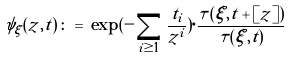<formula> <loc_0><loc_0><loc_500><loc_500>\psi _ { \xi } ( z , t ) \, \colon = \, \exp ( - \sum _ { i \geq 1 } \frac { t _ { i } } { z ^ { i } } ) \cdot \frac { \tau ( \xi , t + [ z ] ) } { \tau ( \xi , t ) }</formula> 